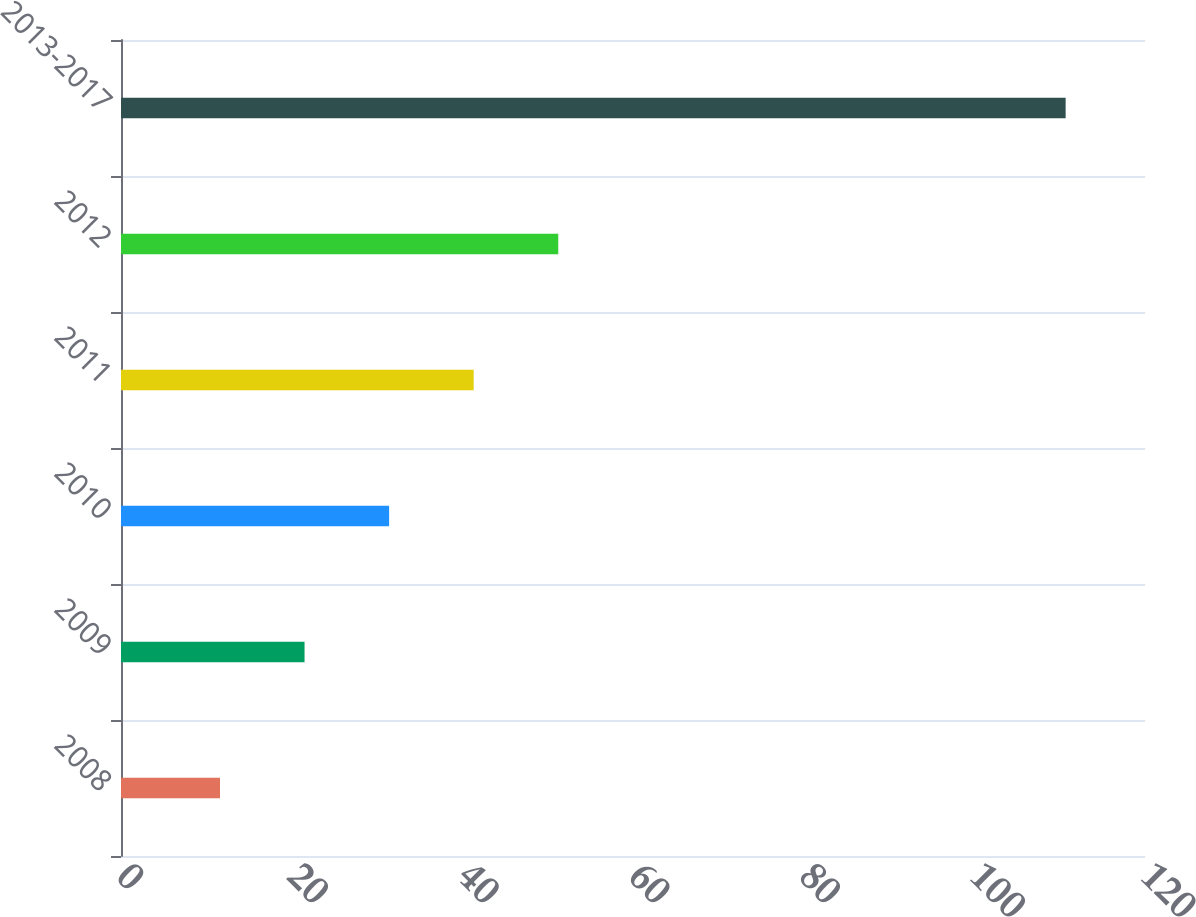Convert chart to OTSL. <chart><loc_0><loc_0><loc_500><loc_500><bar_chart><fcel>2008<fcel>2009<fcel>2010<fcel>2011<fcel>2012<fcel>2013-2017<nl><fcel>11.6<fcel>21.51<fcel>31.42<fcel>41.33<fcel>51.24<fcel>110.7<nl></chart> 